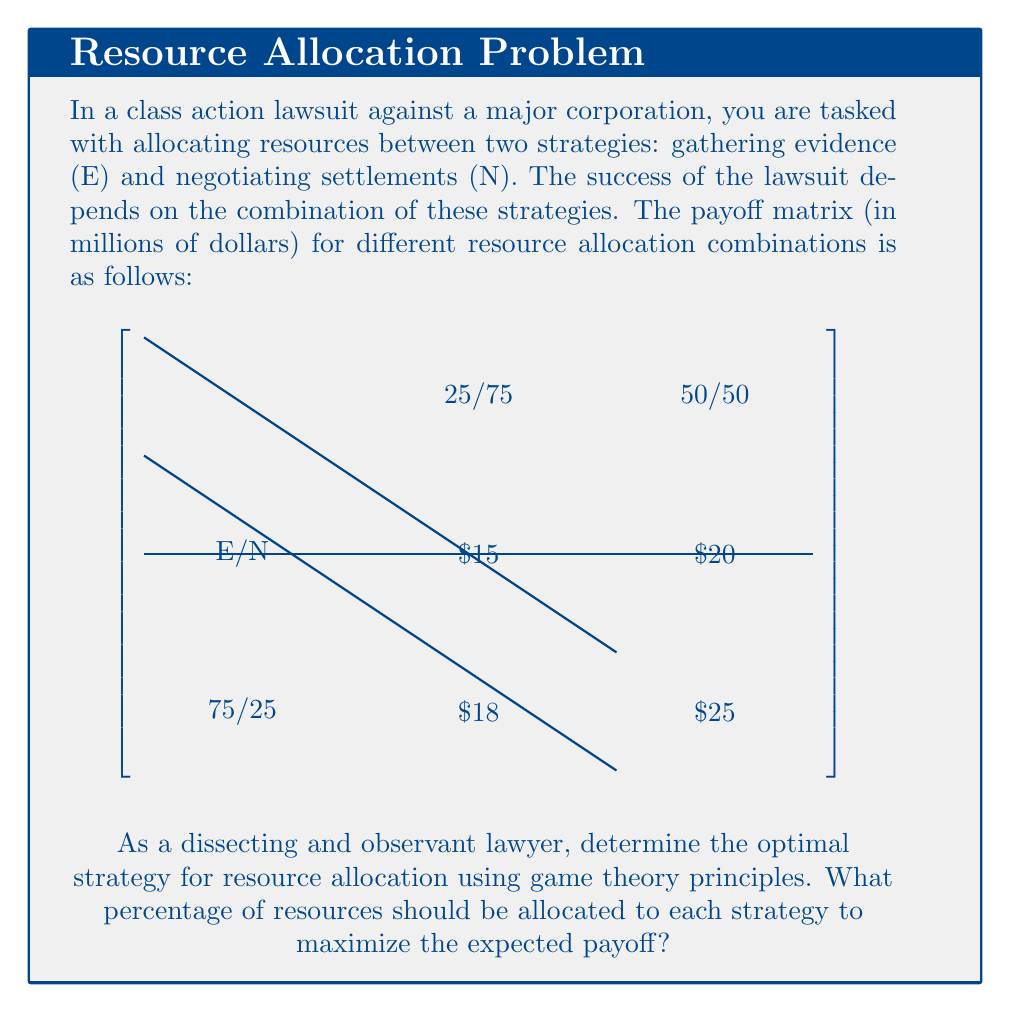Help me with this question. To solve this problem, we'll use the concept of mixed strategies in game theory. Let's approach this step-by-step:

1) Let $p$ be the probability of choosing the 75/25 (E/N) strategy, and $(1-p)$ be the probability of choosing the 50/50 strategy.

2) The expected payoff for each pure strategy of the corporation can be calculated as:
   For E/N (top row): $18p + 15(1-p) = 18p + 15 - 15p = 3p + 15$
   For 50/50 (bottom row): $25p + 20(1-p) = 25p + 20 - 20p = 5p + 20$

3) In a mixed strategy equilibrium, these expected payoffs should be equal:
   $3p + 15 = 5p + 20$

4) Solving this equation:
   $3p + 15 = 5p + 20$
   $15 - 20 = 5p - 3p$
   $-5 = 2p$
   $p = -2.5$

5) However, since probabilities must be between 0 and 1, this solution is not feasible. This means that there is no mixed strategy equilibrium, and the optimal strategy must be one of the pure strategies.

6) Comparing the payoffs:
   75/25 (E/N) strategy: $18 million
   50/50 strategy: $25 million

7) The 50/50 strategy yields a higher payoff.

Therefore, the optimal strategy is to allocate resources equally between gathering evidence (E) and negotiating settlements (N).
Answer: 50% to evidence gathering, 50% to negotiating settlements 